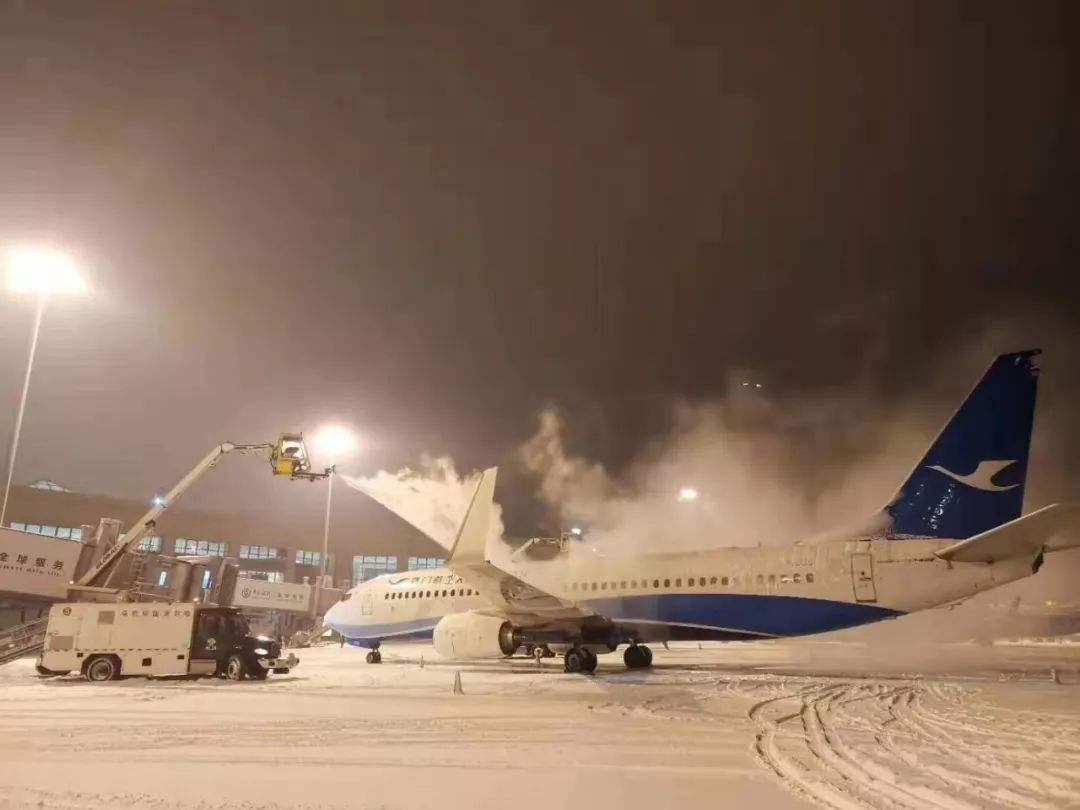What is happening in the image with the airplane? The image shows an airplane undergoing a de-icing process. A de-icing vehicle is spraying the aircraft with a fluid to remove ice and snow, which helps prevent any build-up that could impair the airplane's performance during takeoff and flight. 